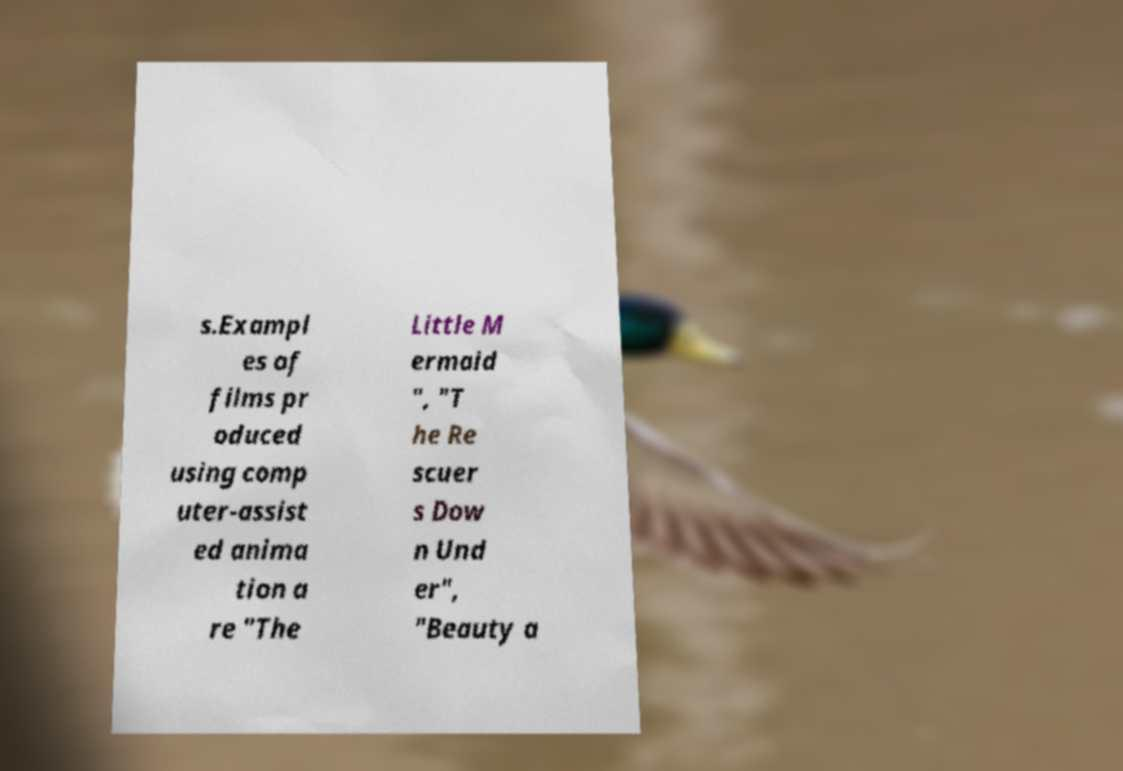Could you extract and type out the text from this image? s.Exampl es of films pr oduced using comp uter-assist ed anima tion a re "The Little M ermaid ", "T he Re scuer s Dow n Und er", "Beauty a 